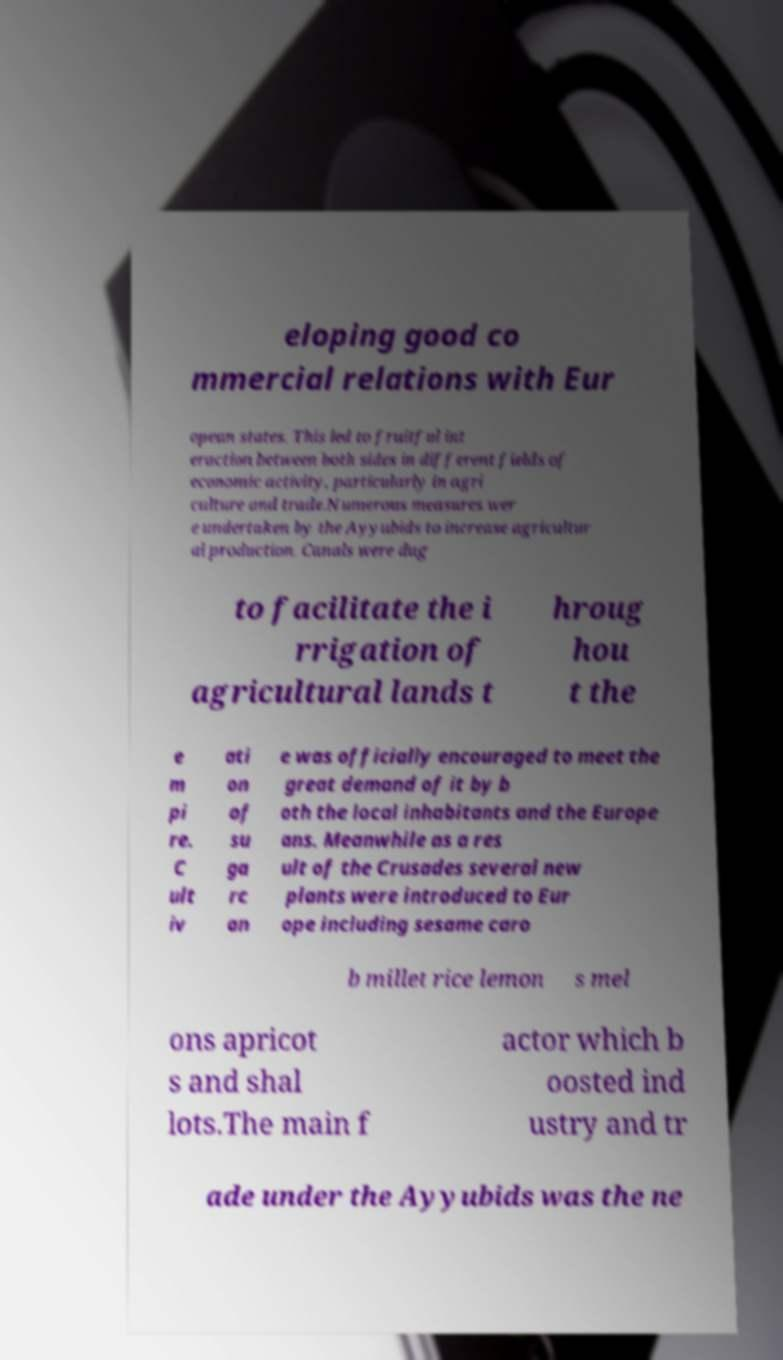Can you read and provide the text displayed in the image?This photo seems to have some interesting text. Can you extract and type it out for me? eloping good co mmercial relations with Eur opean states. This led to fruitful int eraction between both sides in different fields of economic activity, particularly in agri culture and trade.Numerous measures wer e undertaken by the Ayyubids to increase agricultur al production. Canals were dug to facilitate the i rrigation of agricultural lands t hroug hou t the e m pi re. C ult iv ati on of su ga rc an e was officially encouraged to meet the great demand of it by b oth the local inhabitants and the Europe ans. Meanwhile as a res ult of the Crusades several new plants were introduced to Eur ope including sesame caro b millet rice lemon s mel ons apricot s and shal lots.The main f actor which b oosted ind ustry and tr ade under the Ayyubids was the ne 